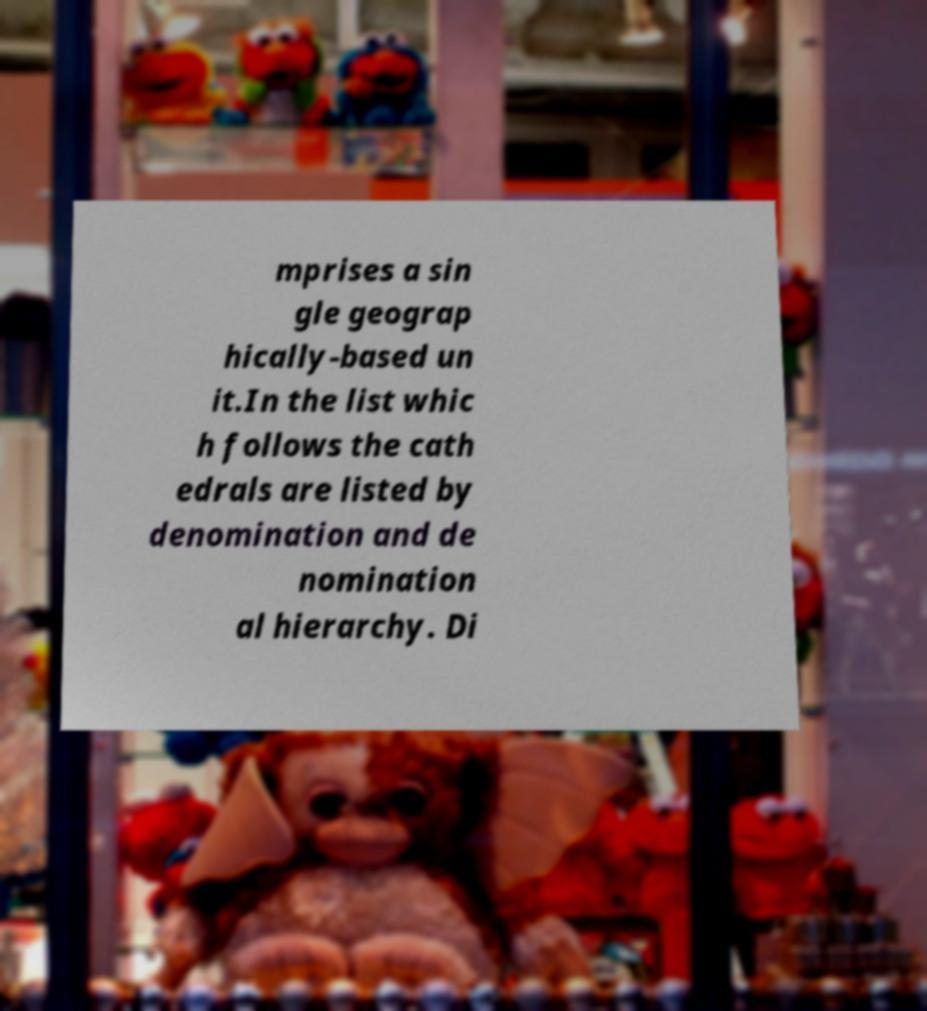What messages or text are displayed in this image? I need them in a readable, typed format. mprises a sin gle geograp hically-based un it.In the list whic h follows the cath edrals are listed by denomination and de nomination al hierarchy. Di 